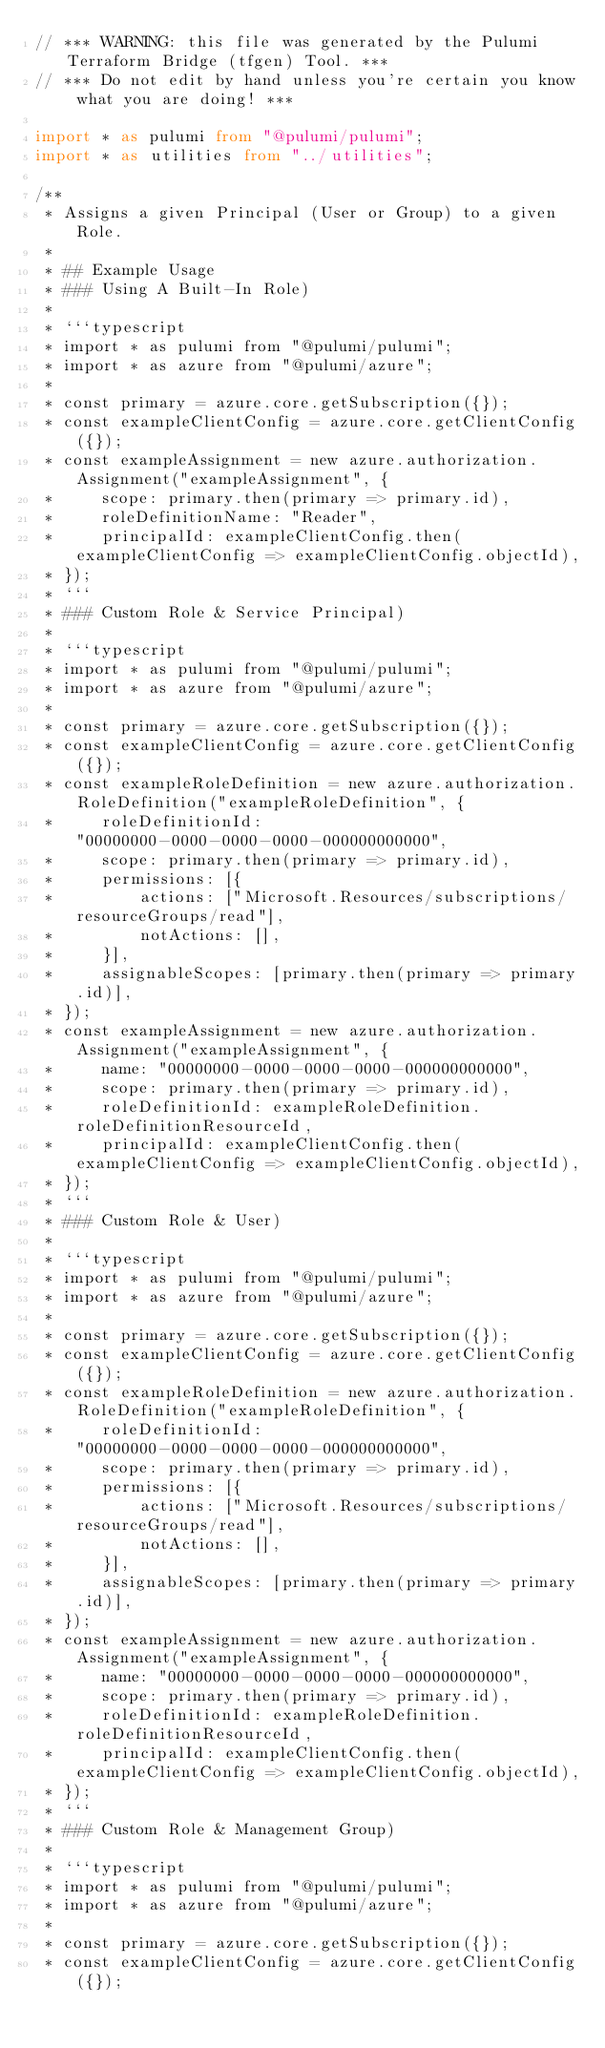<code> <loc_0><loc_0><loc_500><loc_500><_TypeScript_>// *** WARNING: this file was generated by the Pulumi Terraform Bridge (tfgen) Tool. ***
// *** Do not edit by hand unless you're certain you know what you are doing! ***

import * as pulumi from "@pulumi/pulumi";
import * as utilities from "../utilities";

/**
 * Assigns a given Principal (User or Group) to a given Role.
 *
 * ## Example Usage
 * ### Using A Built-In Role)
 *
 * ```typescript
 * import * as pulumi from "@pulumi/pulumi";
 * import * as azure from "@pulumi/azure";
 *
 * const primary = azure.core.getSubscription({});
 * const exampleClientConfig = azure.core.getClientConfig({});
 * const exampleAssignment = new azure.authorization.Assignment("exampleAssignment", {
 *     scope: primary.then(primary => primary.id),
 *     roleDefinitionName: "Reader",
 *     principalId: exampleClientConfig.then(exampleClientConfig => exampleClientConfig.objectId),
 * });
 * ```
 * ### Custom Role & Service Principal)
 *
 * ```typescript
 * import * as pulumi from "@pulumi/pulumi";
 * import * as azure from "@pulumi/azure";
 *
 * const primary = azure.core.getSubscription({});
 * const exampleClientConfig = azure.core.getClientConfig({});
 * const exampleRoleDefinition = new azure.authorization.RoleDefinition("exampleRoleDefinition", {
 *     roleDefinitionId: "00000000-0000-0000-0000-000000000000",
 *     scope: primary.then(primary => primary.id),
 *     permissions: [{
 *         actions: ["Microsoft.Resources/subscriptions/resourceGroups/read"],
 *         notActions: [],
 *     }],
 *     assignableScopes: [primary.then(primary => primary.id)],
 * });
 * const exampleAssignment = new azure.authorization.Assignment("exampleAssignment", {
 *     name: "00000000-0000-0000-0000-000000000000",
 *     scope: primary.then(primary => primary.id),
 *     roleDefinitionId: exampleRoleDefinition.roleDefinitionResourceId,
 *     principalId: exampleClientConfig.then(exampleClientConfig => exampleClientConfig.objectId),
 * });
 * ```
 * ### Custom Role & User)
 *
 * ```typescript
 * import * as pulumi from "@pulumi/pulumi";
 * import * as azure from "@pulumi/azure";
 *
 * const primary = azure.core.getSubscription({});
 * const exampleClientConfig = azure.core.getClientConfig({});
 * const exampleRoleDefinition = new azure.authorization.RoleDefinition("exampleRoleDefinition", {
 *     roleDefinitionId: "00000000-0000-0000-0000-000000000000",
 *     scope: primary.then(primary => primary.id),
 *     permissions: [{
 *         actions: ["Microsoft.Resources/subscriptions/resourceGroups/read"],
 *         notActions: [],
 *     }],
 *     assignableScopes: [primary.then(primary => primary.id)],
 * });
 * const exampleAssignment = new azure.authorization.Assignment("exampleAssignment", {
 *     name: "00000000-0000-0000-0000-000000000000",
 *     scope: primary.then(primary => primary.id),
 *     roleDefinitionId: exampleRoleDefinition.roleDefinitionResourceId,
 *     principalId: exampleClientConfig.then(exampleClientConfig => exampleClientConfig.objectId),
 * });
 * ```
 * ### Custom Role & Management Group)
 *
 * ```typescript
 * import * as pulumi from "@pulumi/pulumi";
 * import * as azure from "@pulumi/azure";
 *
 * const primary = azure.core.getSubscription({});
 * const exampleClientConfig = azure.core.getClientConfig({});</code> 